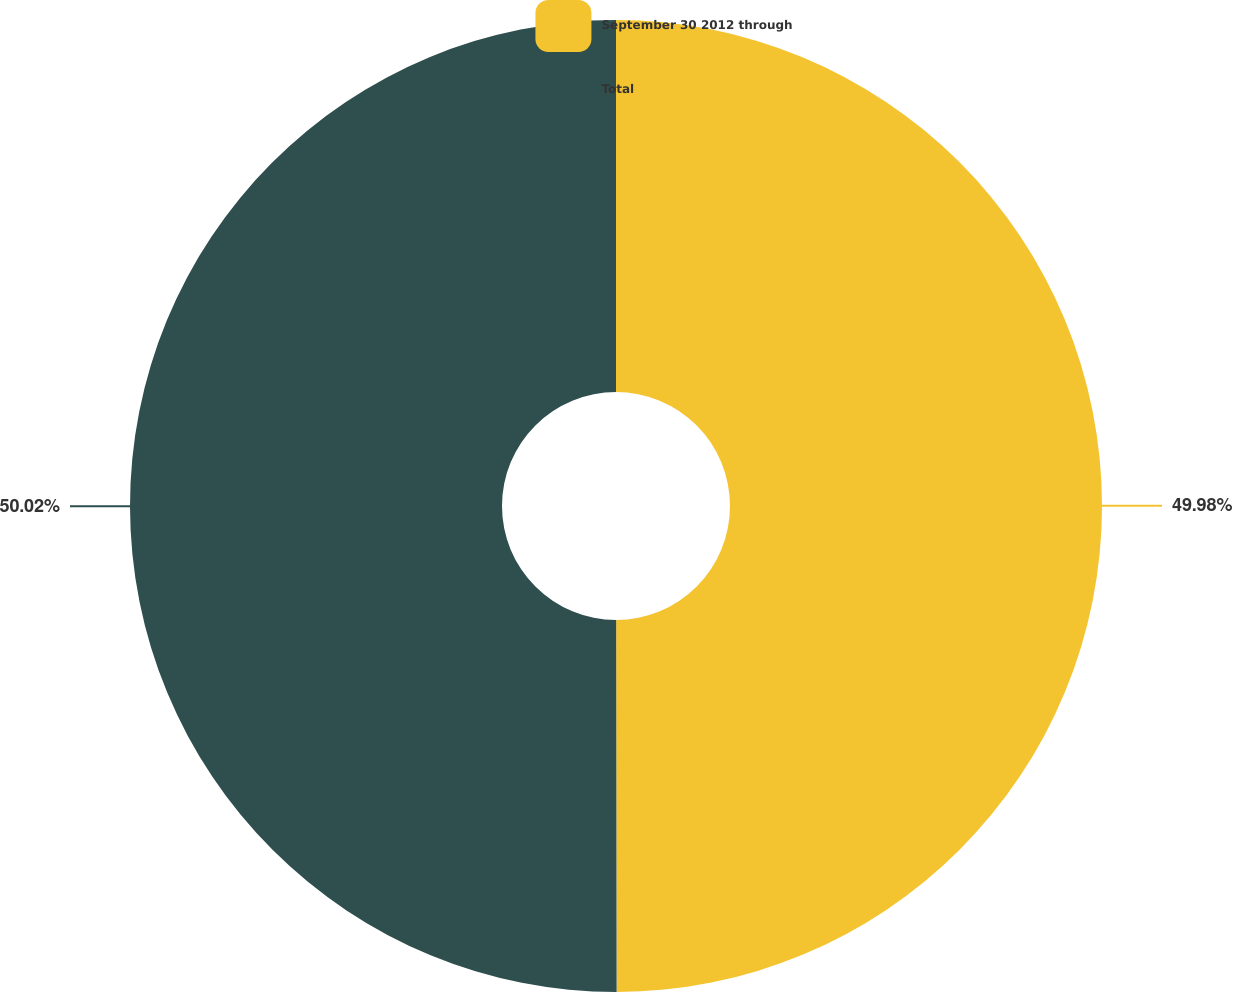<chart> <loc_0><loc_0><loc_500><loc_500><pie_chart><fcel>September 30 2012 through<fcel>Total<nl><fcel>49.98%<fcel>50.02%<nl></chart> 